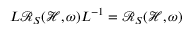Convert formula to latex. <formula><loc_0><loc_0><loc_500><loc_500>L \mathcal { R } _ { S } ( \mathcal { H } , \omega ) L ^ { - 1 } = \mathcal { R } _ { S } ( \mathcal { H } , \omega )</formula> 